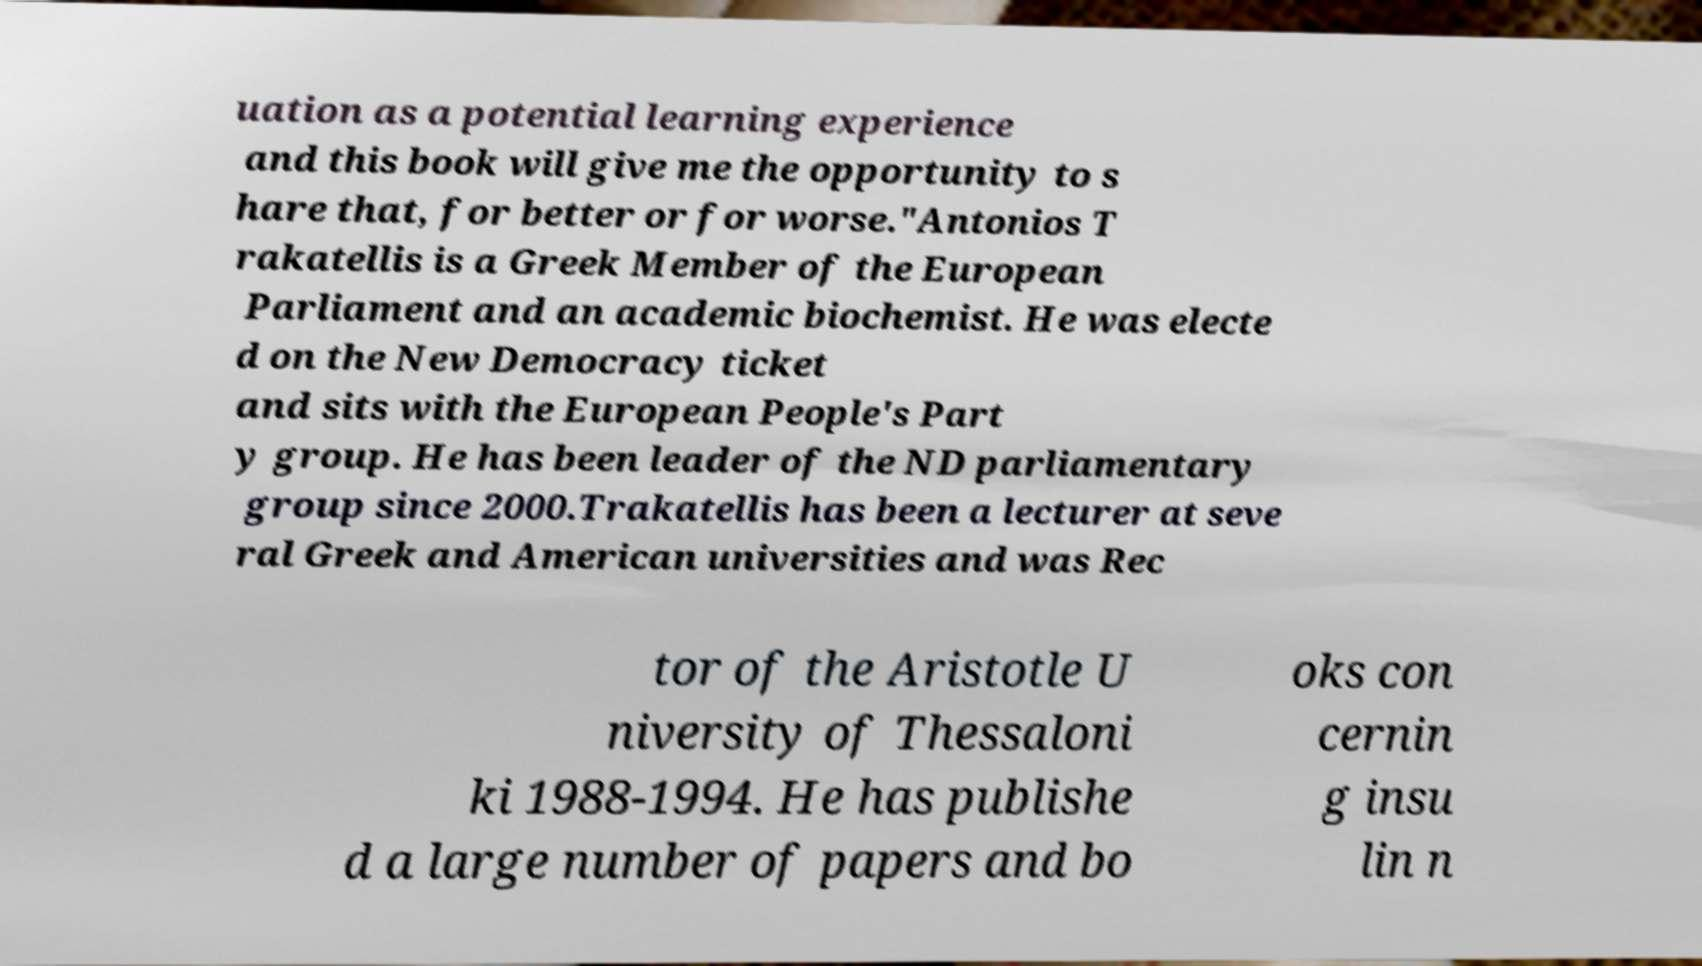There's text embedded in this image that I need extracted. Can you transcribe it verbatim? uation as a potential learning experience and this book will give me the opportunity to s hare that, for better or for worse."Antonios T rakatellis is a Greek Member of the European Parliament and an academic biochemist. He was electe d on the New Democracy ticket and sits with the European People's Part y group. He has been leader of the ND parliamentary group since 2000.Trakatellis has been a lecturer at seve ral Greek and American universities and was Rec tor of the Aristotle U niversity of Thessaloni ki 1988-1994. He has publishe d a large number of papers and bo oks con cernin g insu lin n 